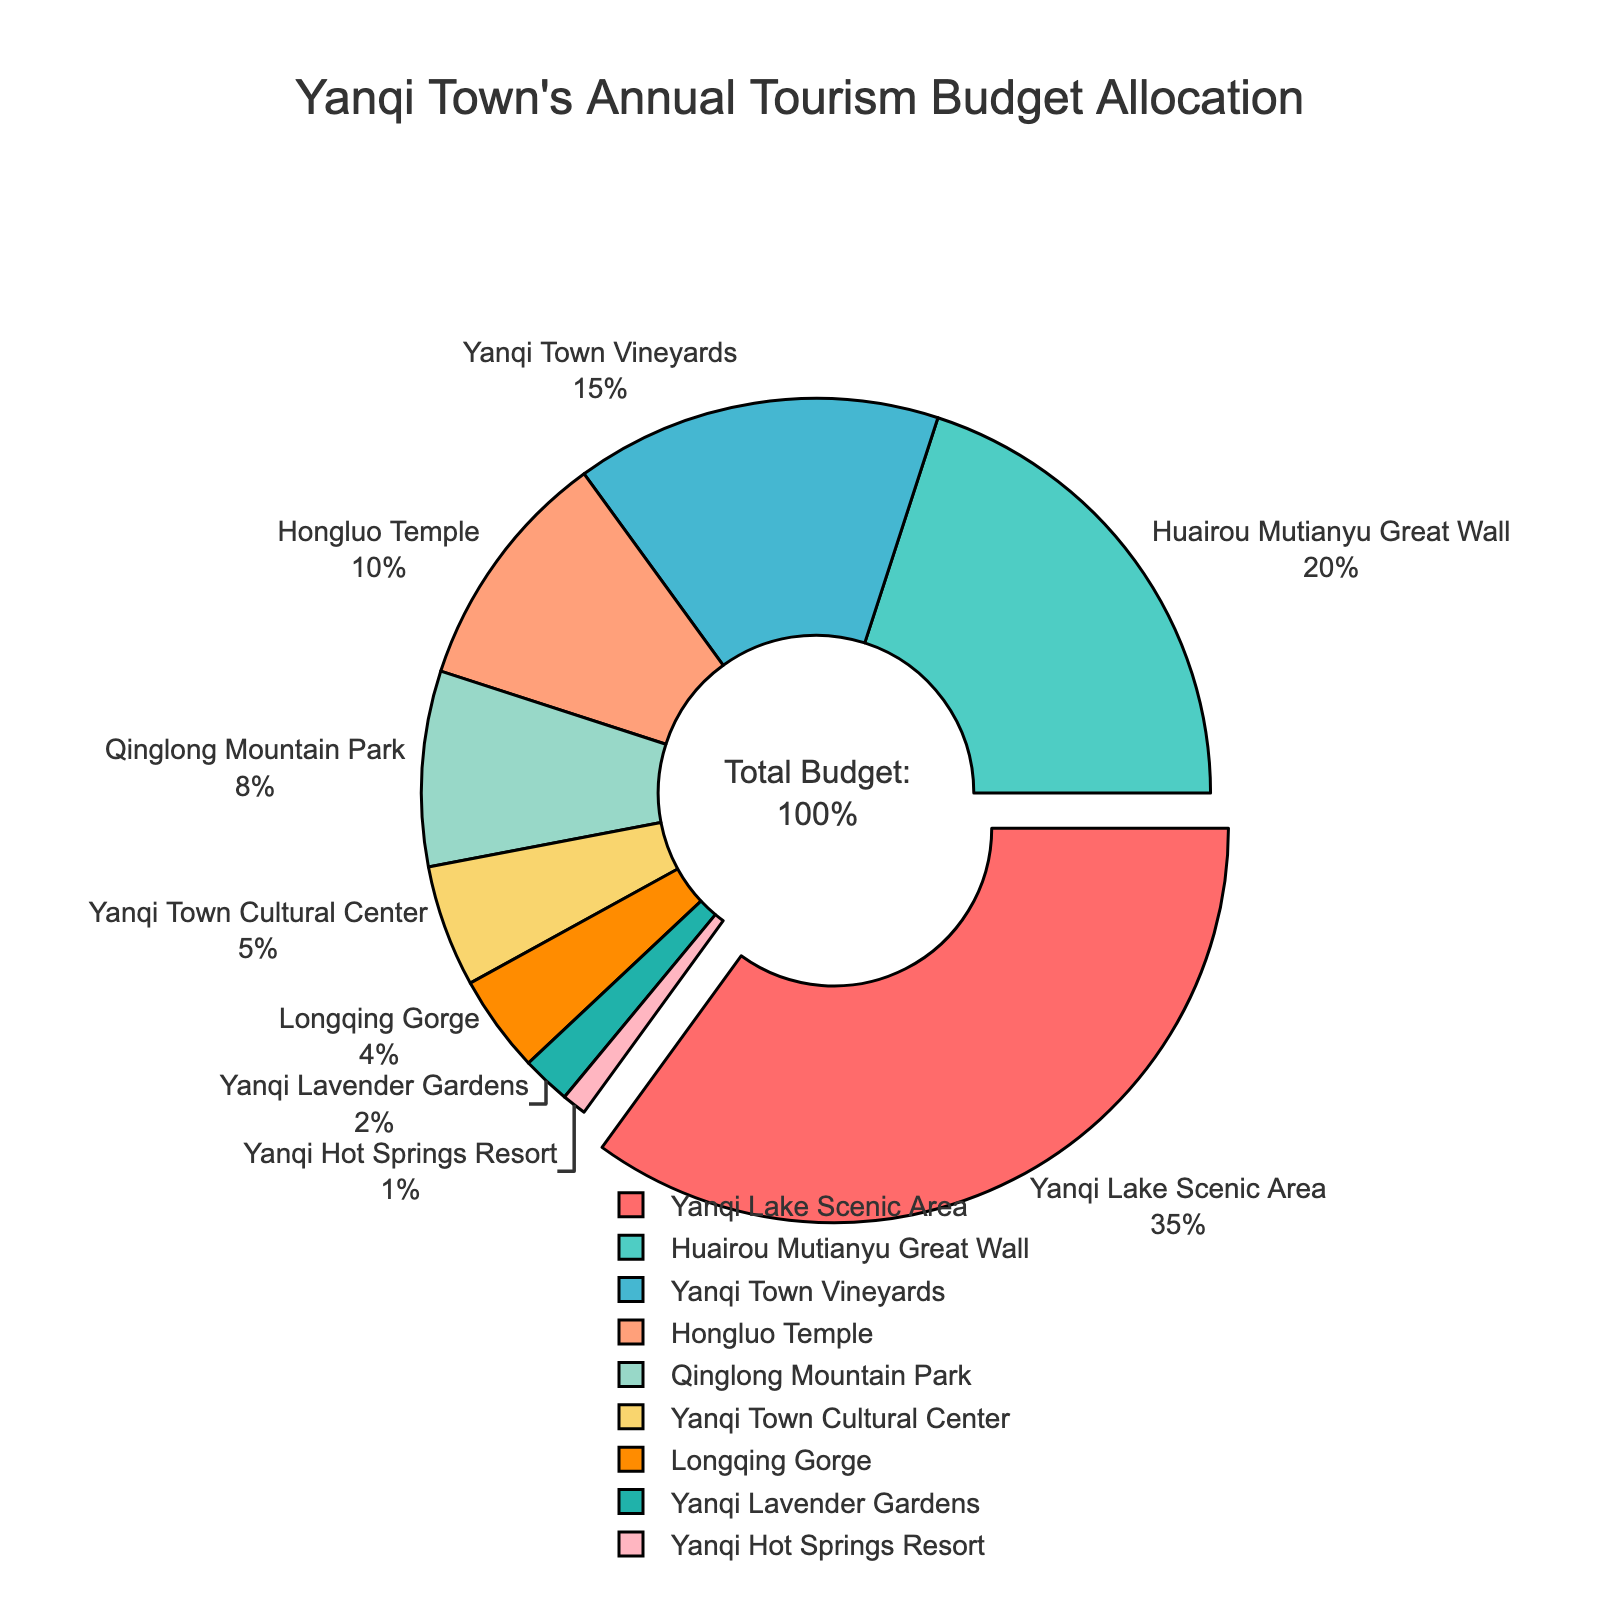what percentage of the budget is allocated to the top two attractions? The top two attractions are Yanqi Lake Scenic Area with 35% and Huairou Mutianyu Great Wall with 20%. Adding these percentages together gives 35% + 20% = 55%.
Answer: 55% which attraction has the smallest budget allocation, and what is its percentage? The attraction with the smallest budget allocation is Yanqi Hot Springs Resort with 1% of the budget.
Answer: Yanqi Hot Springs Resort, 1% how many attractions have a budget allocation of 10% or more? The attractions with a budget allocation of 10% or more are Yanqi Lake Scenic Area (35%), Huairou Mutianyu Great Wall (20%), Yanqi Town Vineyards (15%), and Hongluo Temple (10%). This totals to four attractions.
Answer: 4 what is the difference in budget allocation between Yanqi Town Cultural Center and Qinglong Mountain Park? Yanqi Town Cultural Center has 5% of the budget, while Qinglong Mountain Park has 8%. The difference is 8% - 5% = 3%.
Answer: 3% how does the budget allocation for Yanqi Town Vineyards compare to that of Hongluo Temple? Yanqi Town Vineyards have a 15% allocation, whereas Hongluo Temple has a 10% allocation. Therefore, Yanqi Town Vineyards have a 5% higher budget allocation than Hongluo Temple.
Answer: Yanqi Town Vineyards has 5% higher which attraction stands out visually, and why? Yanqi Lake Scenic Area stands out visually because it is pulled out of the pie chart, making it more prominent than other sections, and also has the largest slice at 35%.
Answer: Yanqi Lake Scenic Area what is the combined budget allocation for the bottom three attractions? The bottom three attractions are Yanqi Town Cultural Center (5%), Longqing Gorge (4%), and Yanqi Lavender Gardens (2%). Adding these percentages together gives 5% + 4% + 2% = 11%.
Answer: 11% if an attraction's budget was to be increased by 5%, which attraction would then have the highest allocation? The current highest allocation is Yanqi Lake Scenic Area with 35%. If Huairou Mutianyu Great Wall (currently 20%) were increased by 5%, it would have 25%, still less than Yanqi Lake Scenic Area. Therefore, Yanqi Lake Scenic Area would remain the highest.
Answer: Yanqi Lake Scenic Area which attractions have a budget allocation less than 10%, and what is their total allocation? Qinglong Mountain Park (8%), Yanqi Town Cultural Center (5%), Longqing Gorge (4%), Yanqi Lavender Gardens (2%), and Yanqi Hot Springs Resort (1%) all have budget allocations under 10%. Adding these percentages together gives 8% + 5% + 4% + 2% + 1% = 20%.
Answer: 20% 